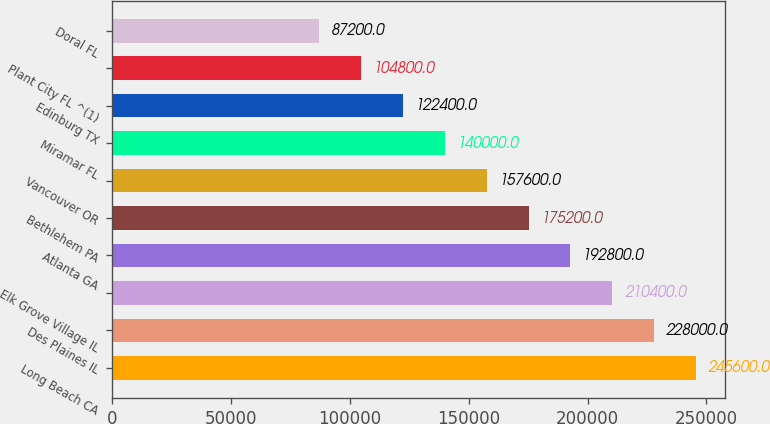Convert chart. <chart><loc_0><loc_0><loc_500><loc_500><bar_chart><fcel>Long Beach CA<fcel>Des Plaines IL<fcel>Elk Grove Village IL<fcel>Atlanta GA<fcel>Bethlehem PA<fcel>Vancouver OR<fcel>Miramar FL<fcel>Edinburg TX<fcel>Plant City FL ^(1)<fcel>Doral FL<nl><fcel>245600<fcel>228000<fcel>210400<fcel>192800<fcel>175200<fcel>157600<fcel>140000<fcel>122400<fcel>104800<fcel>87200<nl></chart> 